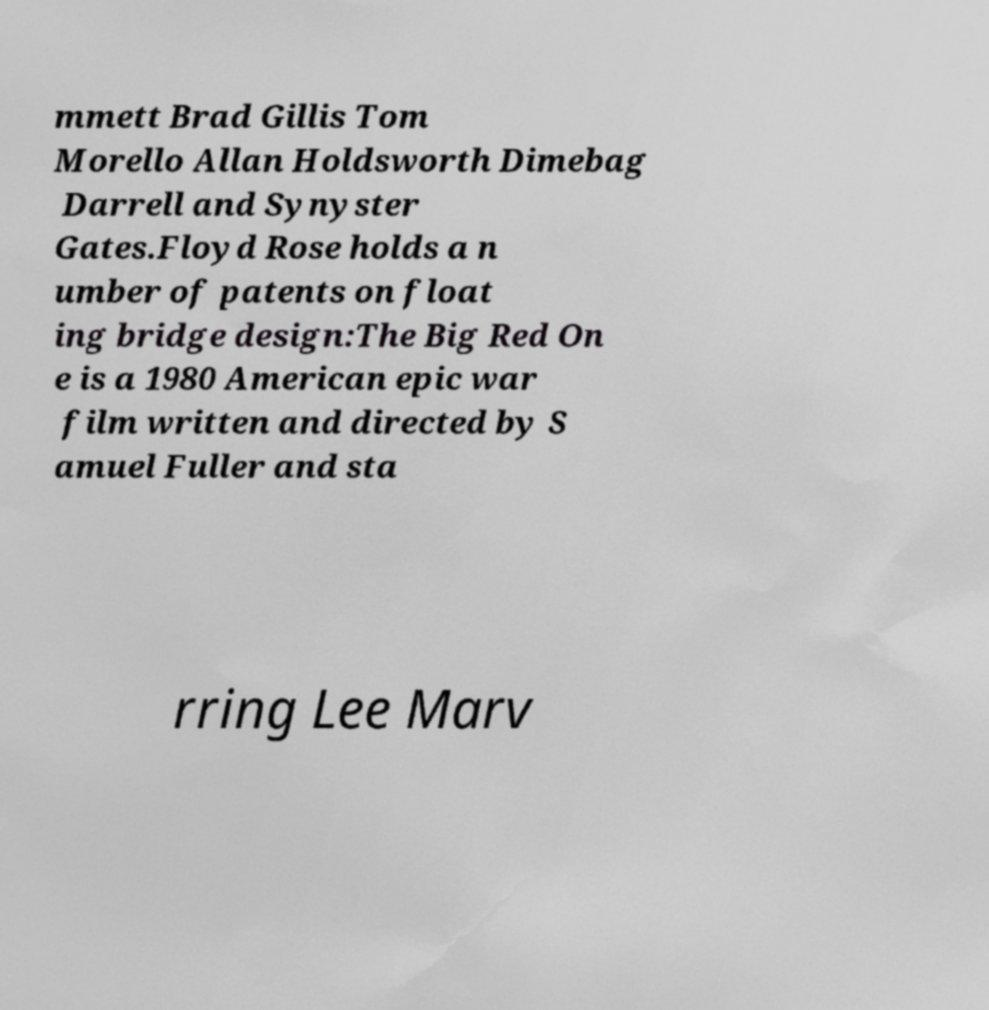Could you extract and type out the text from this image? mmett Brad Gillis Tom Morello Allan Holdsworth Dimebag Darrell and Synyster Gates.Floyd Rose holds a n umber of patents on float ing bridge design:The Big Red On e is a 1980 American epic war film written and directed by S amuel Fuller and sta rring Lee Marv 